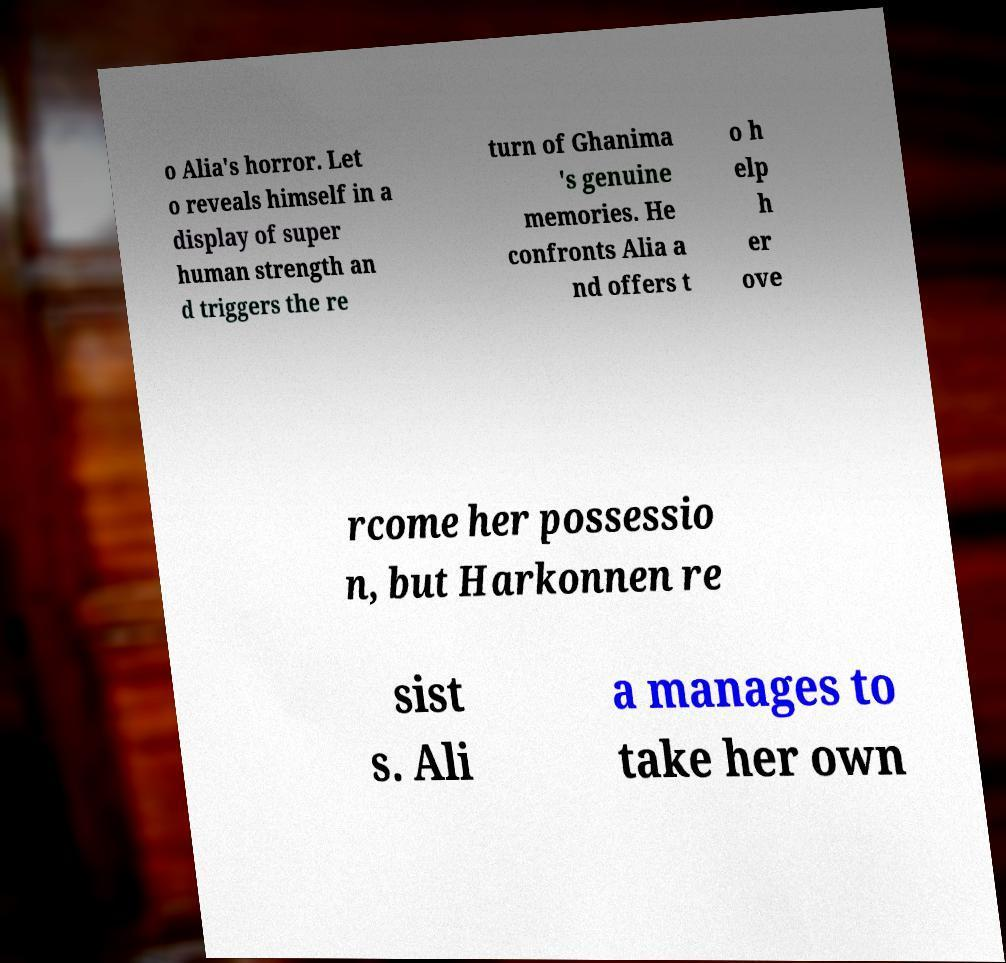Please read and relay the text visible in this image. What does it say? o Alia's horror. Let o reveals himself in a display of super human strength an d triggers the re turn of Ghanima 's genuine memories. He confronts Alia a nd offers t o h elp h er ove rcome her possessio n, but Harkonnen re sist s. Ali a manages to take her own 